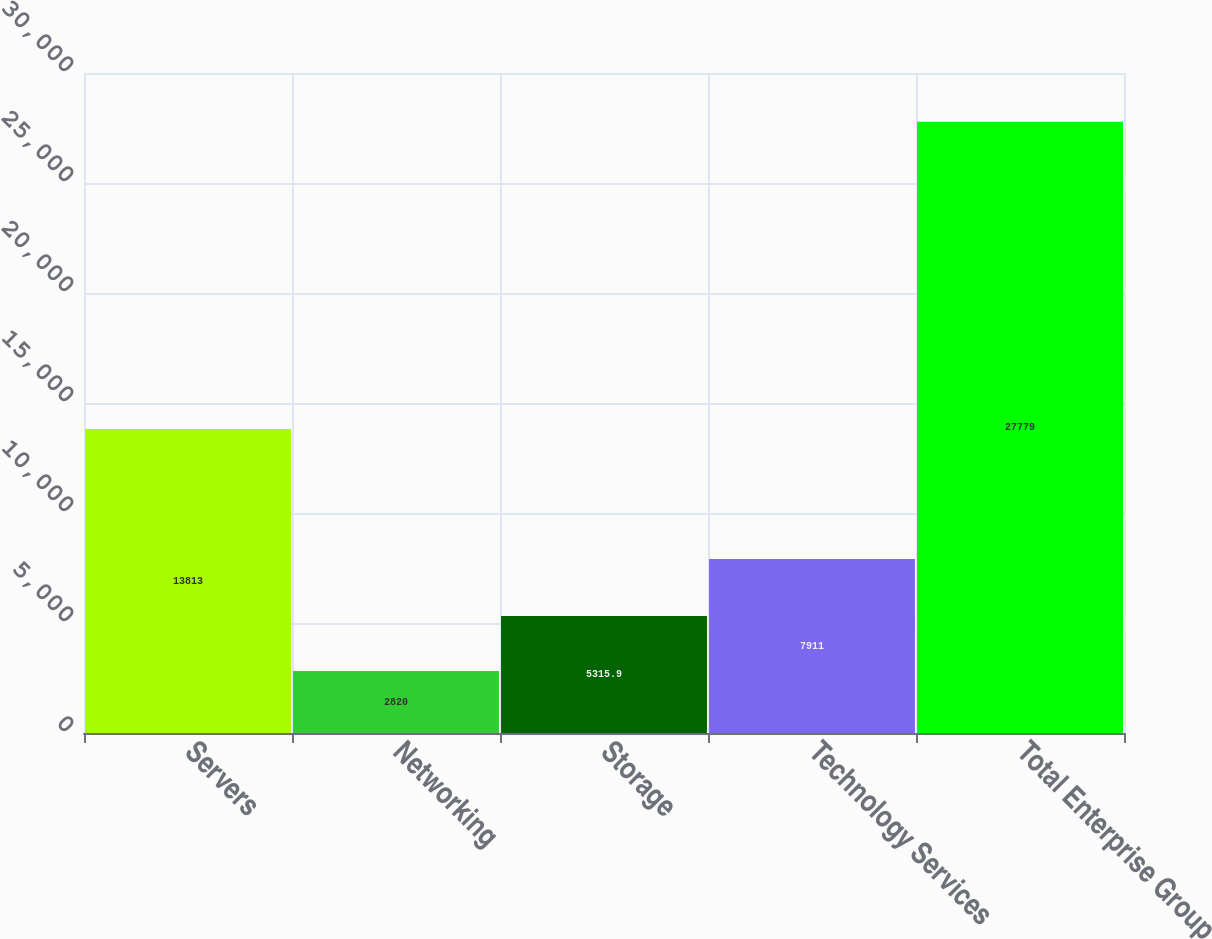Convert chart to OTSL. <chart><loc_0><loc_0><loc_500><loc_500><bar_chart><fcel>Servers<fcel>Networking<fcel>Storage<fcel>Technology Services<fcel>Total Enterprise Group<nl><fcel>13813<fcel>2820<fcel>5315.9<fcel>7911<fcel>27779<nl></chart> 